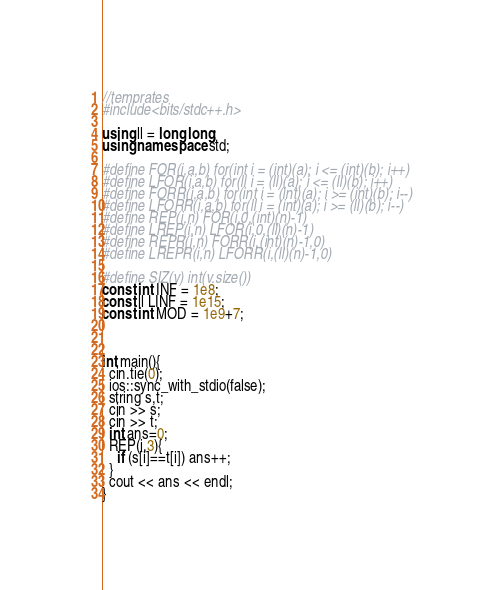Convert code to text. <code><loc_0><loc_0><loc_500><loc_500><_C++_>//temprates
#include<bits/stdc++.h>

using ll = long long;
using namespace std;

#define FOR(i,a,b) for(int i = (int)(a); i <= (int)(b); i++)
#define LFOR(i,a,b) for(ll i = (ll)(a); i <= (ll)(b); i++)
#define FORR(i,a,b) for(int i = (int)(a); i >= (int)(b); i--)
#define LFORR(i,a,b) for(ll i = (int)(a); i >= (ll)(b); i--)
#define REP(i,n) FOR(i,0,(int)(n)-1)
#define LREP(i,n) LFOR(i,0,(ll)(n)-1)
#define REPR(i,n) FORR(i,(int)(n)-1,0)
#define LREPR(i,n) LFORR(i,(ll)(n)-1,0)

#define SIZ(v) int(v.size())
const int INF = 1e8;
const ll LINF = 1e15;
const int MOD = 1e9+7;



int main(){
  cin.tie(0);
  ios::sync_with_stdio(false);
  string s,t;
  cin >> s;
  cin >> t;
  int ans=0;
  REP(i,3){
    if (s[i]==t[i]) ans++;
  }
  cout << ans << endl;
}</code> 